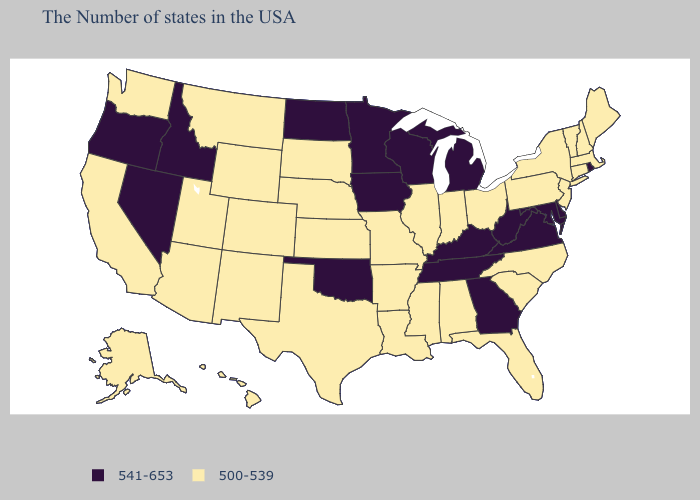Does the first symbol in the legend represent the smallest category?
Concise answer only. No. Name the states that have a value in the range 541-653?
Concise answer only. Rhode Island, Delaware, Maryland, Virginia, West Virginia, Georgia, Michigan, Kentucky, Tennessee, Wisconsin, Minnesota, Iowa, Oklahoma, North Dakota, Idaho, Nevada, Oregon. What is the highest value in the MidWest ?
Short answer required. 541-653. Which states have the highest value in the USA?
Keep it brief. Rhode Island, Delaware, Maryland, Virginia, West Virginia, Georgia, Michigan, Kentucky, Tennessee, Wisconsin, Minnesota, Iowa, Oklahoma, North Dakota, Idaho, Nevada, Oregon. Which states hav the highest value in the West?
Write a very short answer. Idaho, Nevada, Oregon. Which states have the lowest value in the MidWest?
Short answer required. Ohio, Indiana, Illinois, Missouri, Kansas, Nebraska, South Dakota. How many symbols are there in the legend?
Short answer required. 2. Name the states that have a value in the range 541-653?
Be succinct. Rhode Island, Delaware, Maryland, Virginia, West Virginia, Georgia, Michigan, Kentucky, Tennessee, Wisconsin, Minnesota, Iowa, Oklahoma, North Dakota, Idaho, Nevada, Oregon. Does Kansas have the highest value in the MidWest?
Write a very short answer. No. Does Rhode Island have the highest value in the Northeast?
Be succinct. Yes. What is the value of West Virginia?
Be succinct. 541-653. Which states have the highest value in the USA?
Be succinct. Rhode Island, Delaware, Maryland, Virginia, West Virginia, Georgia, Michigan, Kentucky, Tennessee, Wisconsin, Minnesota, Iowa, Oklahoma, North Dakota, Idaho, Nevada, Oregon. What is the value of New York?
Quick response, please. 500-539. Name the states that have a value in the range 541-653?
Give a very brief answer. Rhode Island, Delaware, Maryland, Virginia, West Virginia, Georgia, Michigan, Kentucky, Tennessee, Wisconsin, Minnesota, Iowa, Oklahoma, North Dakota, Idaho, Nevada, Oregon. Name the states that have a value in the range 500-539?
Give a very brief answer. Maine, Massachusetts, New Hampshire, Vermont, Connecticut, New York, New Jersey, Pennsylvania, North Carolina, South Carolina, Ohio, Florida, Indiana, Alabama, Illinois, Mississippi, Louisiana, Missouri, Arkansas, Kansas, Nebraska, Texas, South Dakota, Wyoming, Colorado, New Mexico, Utah, Montana, Arizona, California, Washington, Alaska, Hawaii. 